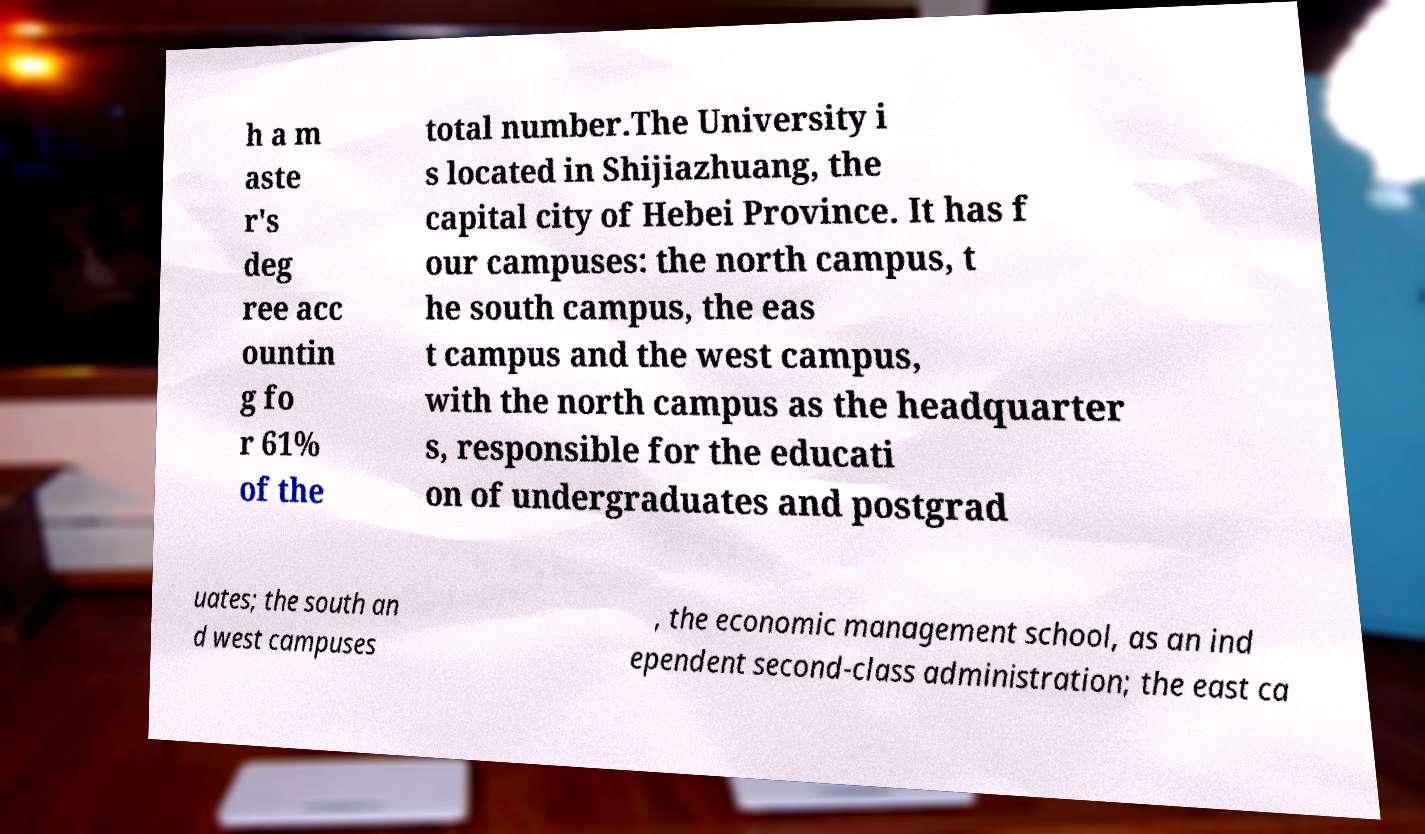I need the written content from this picture converted into text. Can you do that? h a m aste r's deg ree acc ountin g fo r 61% of the total number.The University i s located in Shijiazhuang, the capital city of Hebei Province. It has f our campuses: the north campus, t he south campus, the eas t campus and the west campus, with the north campus as the headquarter s, responsible for the educati on of undergraduates and postgrad uates; the south an d west campuses , the economic management school, as an ind ependent second-class administration; the east ca 